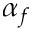Convert formula to latex. <formula><loc_0><loc_0><loc_500><loc_500>\alpha _ { f }</formula> 